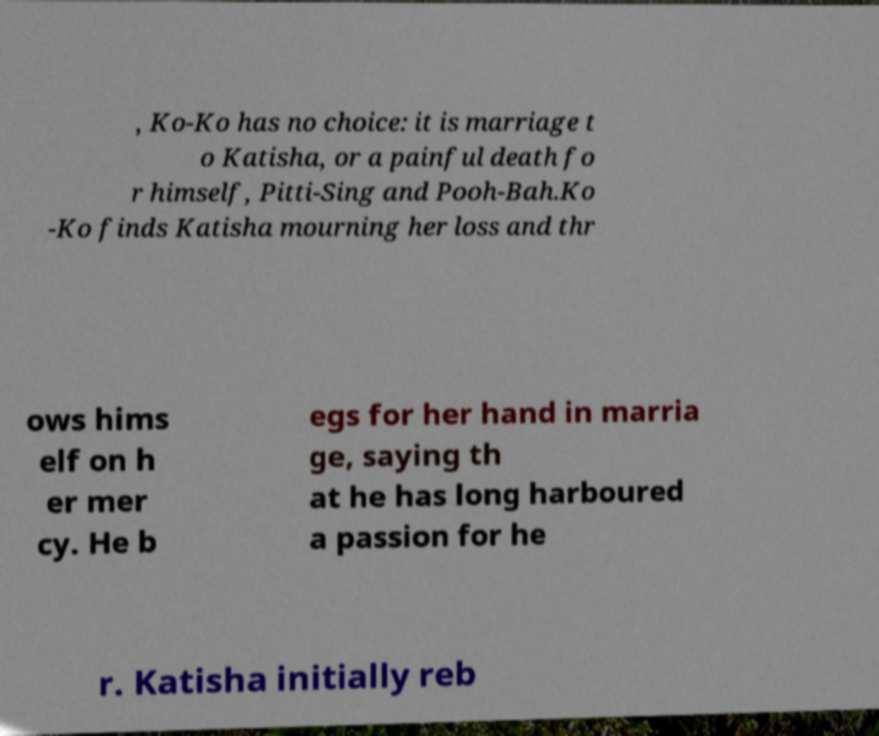Could you extract and type out the text from this image? , Ko-Ko has no choice: it is marriage t o Katisha, or a painful death fo r himself, Pitti-Sing and Pooh-Bah.Ko -Ko finds Katisha mourning her loss and thr ows hims elf on h er mer cy. He b egs for her hand in marria ge, saying th at he has long harboured a passion for he r. Katisha initially reb 